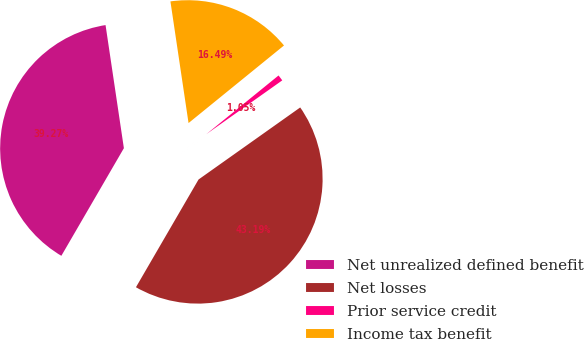Convert chart. <chart><loc_0><loc_0><loc_500><loc_500><pie_chart><fcel>Net unrealized defined benefit<fcel>Net losses<fcel>Prior service credit<fcel>Income tax benefit<nl><fcel>39.27%<fcel>43.19%<fcel>1.05%<fcel>16.49%<nl></chart> 